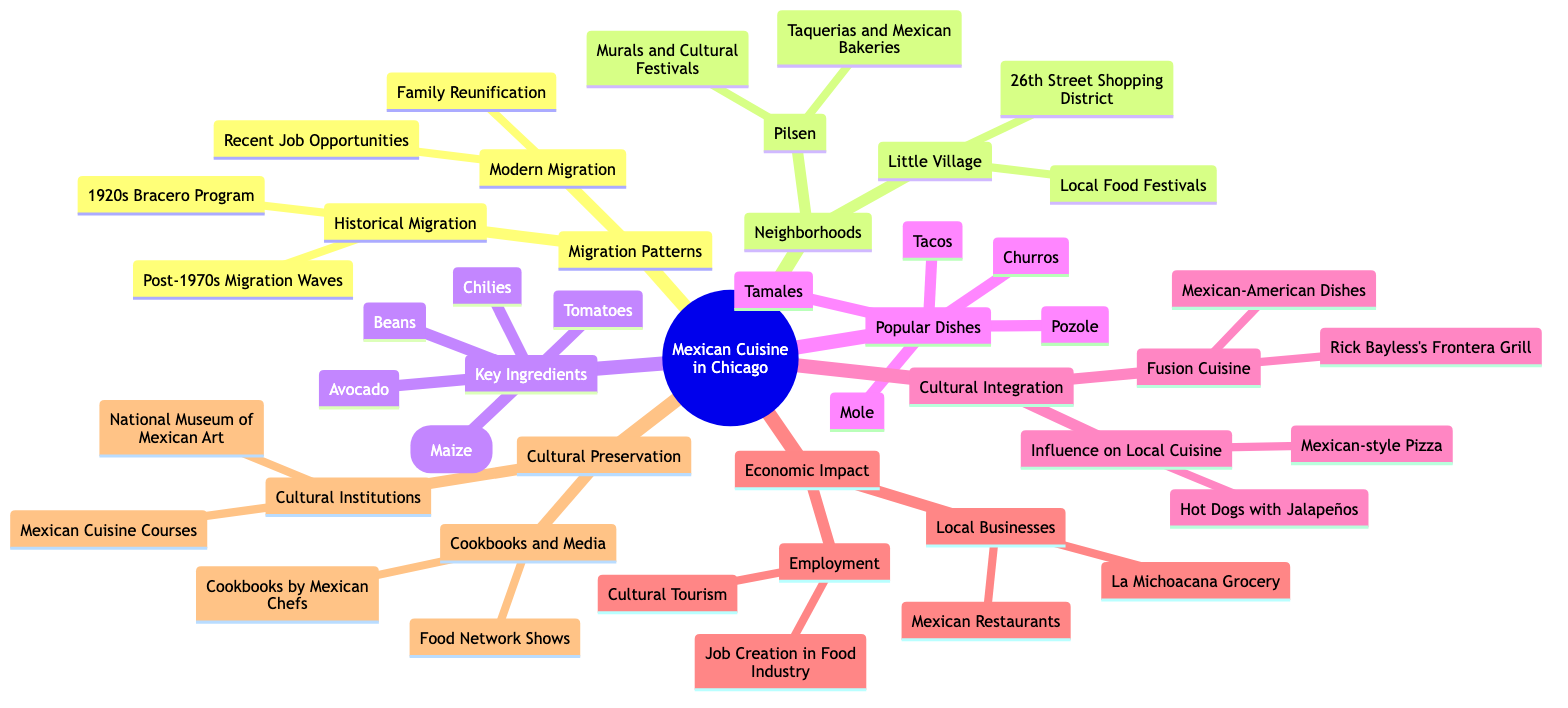What are the neighborhoods mentioned in the diagram? The diagram lists the neighborhoods "Pilsen" and "Little Village" under the "Neighborhoods" element. These are the only neighborhoods explicitly noted in this conceptual structure.
Answer: Pilsen, Little Village How many key ingredients are identified in the diagram? Under the "Key Ingredients" element, there are five ingredients specified: Corn (Maize), Chilies, Beans, Avocado, and Tomatoes. Thus, the total count is five.
Answer: 5 What is a popular dish mentioned in Chicago's Mexican cuisine? The "Popular Dishes" section mentions "Tacos," among other dishes. It is directly included in that group as one of the popular offerings in Chicago.
Answer: Tacos What type of cuisine is described under Fusion Cuisine? The "Cultural Integration" section provides "Mexican-American Dishes" as a category of fusion cuisine. This shows the combination of traditional Mexican and American food styles.
Answer: Mexican-American Dishes Which program is associated with historical migration in the diagram? The "1920s Bracero Program" is explicitly stated under "Historical Migration" in the "Migration Patterns" element, indicating it’s an important historical factor for migration.
Answer: 1920s Bracero Program What economic impact is linked to local businesses? "Mexican Restaurants" as well as "La Michoacana Grocery" are included under the "Local Businesses" heading in the "Economic Impact" section, showing that these entities play a significant role economically.
Answer: Mexican Restaurants What cultural institution is mentioned in the context of cultural preservation? The "National Museum of Mexican Art" is specifically mentioned under the "Cultural Institutions" category in the "Cultural Preservation and Education" section, representing a key place for cultural engagement.
Answer: National Museum of Mexican Art What type of events are listed in the Little Village neighborhood? The phrase "Local Food Festivals" is noted in the context of the "Little Village" neighborhood, indicating a celebration of food culture within that community.
Answer: Local Food Festivals What influences the local cuisine according to the diagram? The "Influence on Local Cuisine" section mentions "Mexican-style Pizza," indicating that there has been a direct adaptation of Mexican elements into Chicago's local food scene.
Answer: Mexican-style Pizza 